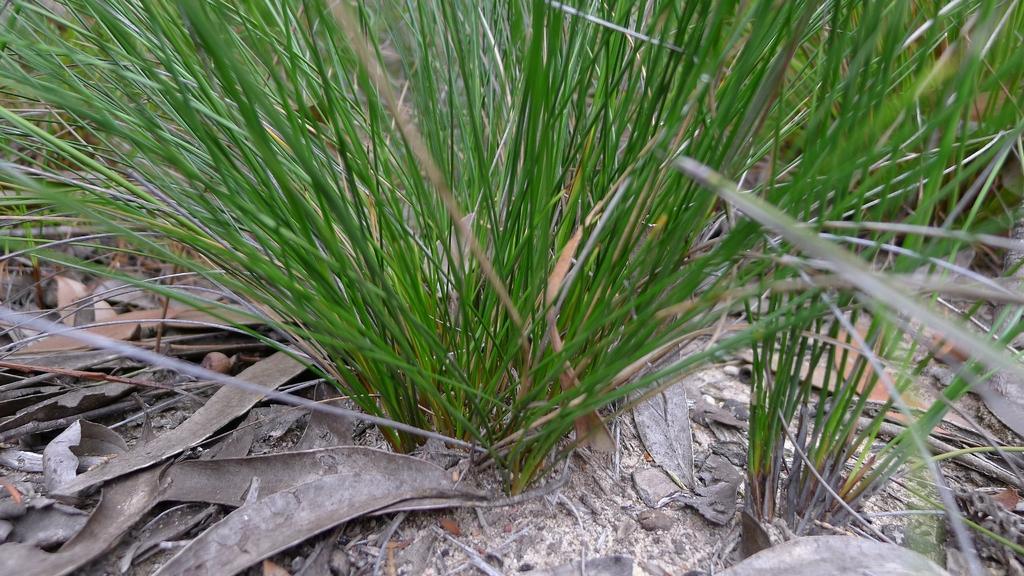Could you give a brief overview of what you see in this image? In this picture we can see grass. 